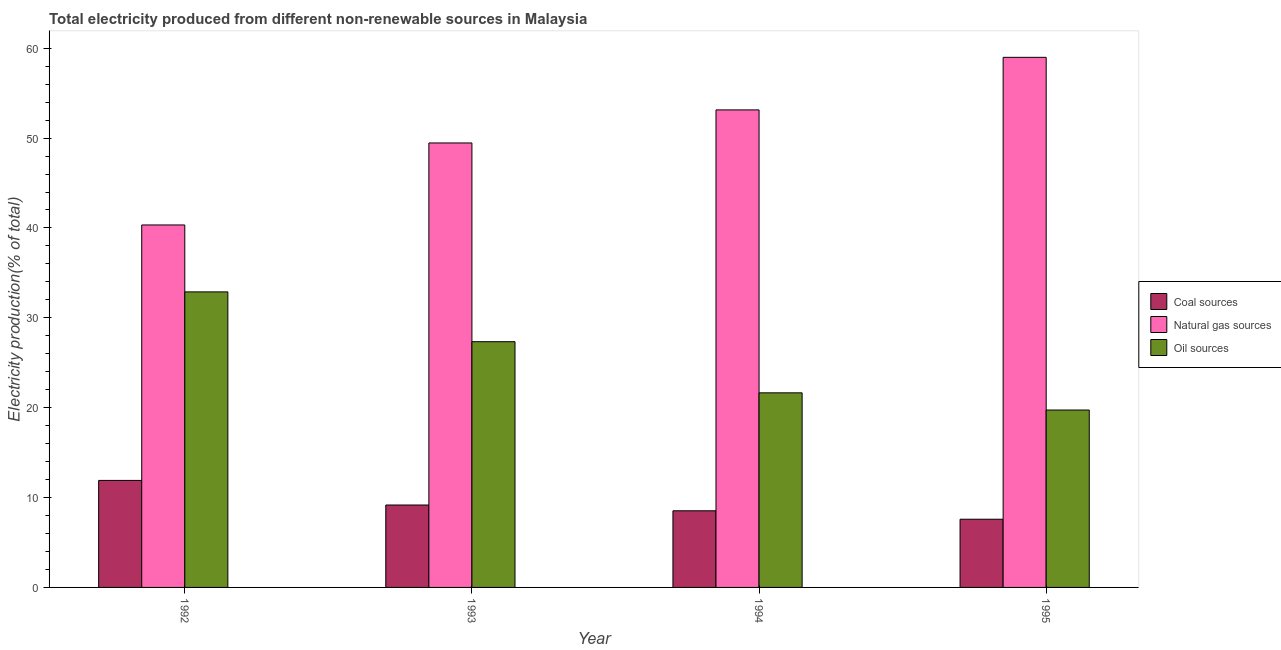How many groups of bars are there?
Keep it short and to the point. 4. What is the percentage of electricity produced by coal in 1994?
Keep it short and to the point. 8.53. Across all years, what is the maximum percentage of electricity produced by oil sources?
Make the answer very short. 32.89. Across all years, what is the minimum percentage of electricity produced by oil sources?
Your response must be concise. 19.74. In which year was the percentage of electricity produced by natural gas maximum?
Your answer should be compact. 1995. In which year was the percentage of electricity produced by coal minimum?
Offer a terse response. 1995. What is the total percentage of electricity produced by oil sources in the graph?
Provide a short and direct response. 101.62. What is the difference between the percentage of electricity produced by coal in 1993 and that in 1994?
Ensure brevity in your answer.  0.64. What is the difference between the percentage of electricity produced by natural gas in 1992 and the percentage of electricity produced by coal in 1995?
Keep it short and to the point. -18.65. What is the average percentage of electricity produced by oil sources per year?
Your answer should be very brief. 25.41. In how many years, is the percentage of electricity produced by coal greater than 8 %?
Provide a succinct answer. 3. What is the ratio of the percentage of electricity produced by oil sources in 1992 to that in 1993?
Offer a very short reply. 1.2. Is the percentage of electricity produced by natural gas in 1994 less than that in 1995?
Provide a short and direct response. Yes. What is the difference between the highest and the second highest percentage of electricity produced by coal?
Give a very brief answer. 2.74. What is the difference between the highest and the lowest percentage of electricity produced by oil sources?
Offer a terse response. 13.15. In how many years, is the percentage of electricity produced by oil sources greater than the average percentage of electricity produced by oil sources taken over all years?
Make the answer very short. 2. What does the 3rd bar from the left in 1994 represents?
Make the answer very short. Oil sources. What does the 1st bar from the right in 1994 represents?
Ensure brevity in your answer.  Oil sources. Is it the case that in every year, the sum of the percentage of electricity produced by coal and percentage of electricity produced by natural gas is greater than the percentage of electricity produced by oil sources?
Give a very brief answer. Yes. What is the difference between two consecutive major ticks on the Y-axis?
Make the answer very short. 10. Does the graph contain any zero values?
Make the answer very short. No. Does the graph contain grids?
Ensure brevity in your answer.  No. Where does the legend appear in the graph?
Provide a succinct answer. Center right. How many legend labels are there?
Offer a very short reply. 3. What is the title of the graph?
Provide a short and direct response. Total electricity produced from different non-renewable sources in Malaysia. What is the label or title of the Y-axis?
Offer a very short reply. Electricity production(% of total). What is the Electricity production(% of total) of Coal sources in 1992?
Offer a very short reply. 11.91. What is the Electricity production(% of total) of Natural gas sources in 1992?
Offer a very short reply. 40.33. What is the Electricity production(% of total) of Oil sources in 1992?
Give a very brief answer. 32.89. What is the Electricity production(% of total) in Coal sources in 1993?
Offer a terse response. 9.17. What is the Electricity production(% of total) of Natural gas sources in 1993?
Provide a short and direct response. 49.46. What is the Electricity production(% of total) in Oil sources in 1993?
Offer a terse response. 27.34. What is the Electricity production(% of total) in Coal sources in 1994?
Provide a short and direct response. 8.53. What is the Electricity production(% of total) of Natural gas sources in 1994?
Keep it short and to the point. 53.14. What is the Electricity production(% of total) in Oil sources in 1994?
Offer a terse response. 21.65. What is the Electricity production(% of total) of Coal sources in 1995?
Make the answer very short. 7.59. What is the Electricity production(% of total) in Natural gas sources in 1995?
Offer a very short reply. 58.99. What is the Electricity production(% of total) of Oil sources in 1995?
Your answer should be very brief. 19.74. Across all years, what is the maximum Electricity production(% of total) of Coal sources?
Your answer should be compact. 11.91. Across all years, what is the maximum Electricity production(% of total) in Natural gas sources?
Your answer should be very brief. 58.99. Across all years, what is the maximum Electricity production(% of total) in Oil sources?
Give a very brief answer. 32.89. Across all years, what is the minimum Electricity production(% of total) of Coal sources?
Offer a terse response. 7.59. Across all years, what is the minimum Electricity production(% of total) of Natural gas sources?
Keep it short and to the point. 40.33. Across all years, what is the minimum Electricity production(% of total) of Oil sources?
Offer a very short reply. 19.74. What is the total Electricity production(% of total) of Coal sources in the graph?
Make the answer very short. 37.19. What is the total Electricity production(% of total) of Natural gas sources in the graph?
Offer a terse response. 201.91. What is the total Electricity production(% of total) in Oil sources in the graph?
Provide a short and direct response. 101.62. What is the difference between the Electricity production(% of total) in Coal sources in 1992 and that in 1993?
Offer a very short reply. 2.74. What is the difference between the Electricity production(% of total) of Natural gas sources in 1992 and that in 1993?
Ensure brevity in your answer.  -9.13. What is the difference between the Electricity production(% of total) in Oil sources in 1992 and that in 1993?
Give a very brief answer. 5.54. What is the difference between the Electricity production(% of total) in Coal sources in 1992 and that in 1994?
Provide a short and direct response. 3.38. What is the difference between the Electricity production(% of total) of Natural gas sources in 1992 and that in 1994?
Provide a short and direct response. -12.8. What is the difference between the Electricity production(% of total) of Oil sources in 1992 and that in 1994?
Your answer should be compact. 11.23. What is the difference between the Electricity production(% of total) of Coal sources in 1992 and that in 1995?
Make the answer very short. 4.32. What is the difference between the Electricity production(% of total) of Natural gas sources in 1992 and that in 1995?
Offer a terse response. -18.65. What is the difference between the Electricity production(% of total) of Oil sources in 1992 and that in 1995?
Give a very brief answer. 13.15. What is the difference between the Electricity production(% of total) in Coal sources in 1993 and that in 1994?
Provide a short and direct response. 0.64. What is the difference between the Electricity production(% of total) of Natural gas sources in 1993 and that in 1994?
Your answer should be very brief. -3.68. What is the difference between the Electricity production(% of total) of Oil sources in 1993 and that in 1994?
Your answer should be very brief. 5.69. What is the difference between the Electricity production(% of total) in Coal sources in 1993 and that in 1995?
Your answer should be very brief. 1.58. What is the difference between the Electricity production(% of total) in Natural gas sources in 1993 and that in 1995?
Ensure brevity in your answer.  -9.53. What is the difference between the Electricity production(% of total) of Oil sources in 1993 and that in 1995?
Give a very brief answer. 7.6. What is the difference between the Electricity production(% of total) in Coal sources in 1994 and that in 1995?
Your answer should be very brief. 0.94. What is the difference between the Electricity production(% of total) in Natural gas sources in 1994 and that in 1995?
Your answer should be compact. -5.85. What is the difference between the Electricity production(% of total) of Oil sources in 1994 and that in 1995?
Provide a short and direct response. 1.91. What is the difference between the Electricity production(% of total) of Coal sources in 1992 and the Electricity production(% of total) of Natural gas sources in 1993?
Ensure brevity in your answer.  -37.55. What is the difference between the Electricity production(% of total) in Coal sources in 1992 and the Electricity production(% of total) in Oil sources in 1993?
Provide a short and direct response. -15.44. What is the difference between the Electricity production(% of total) of Natural gas sources in 1992 and the Electricity production(% of total) of Oil sources in 1993?
Your answer should be compact. 12.99. What is the difference between the Electricity production(% of total) of Coal sources in 1992 and the Electricity production(% of total) of Natural gas sources in 1994?
Keep it short and to the point. -41.23. What is the difference between the Electricity production(% of total) of Coal sources in 1992 and the Electricity production(% of total) of Oil sources in 1994?
Keep it short and to the point. -9.75. What is the difference between the Electricity production(% of total) in Natural gas sources in 1992 and the Electricity production(% of total) in Oil sources in 1994?
Provide a succinct answer. 18.68. What is the difference between the Electricity production(% of total) in Coal sources in 1992 and the Electricity production(% of total) in Natural gas sources in 1995?
Offer a very short reply. -47.08. What is the difference between the Electricity production(% of total) of Coal sources in 1992 and the Electricity production(% of total) of Oil sources in 1995?
Ensure brevity in your answer.  -7.83. What is the difference between the Electricity production(% of total) in Natural gas sources in 1992 and the Electricity production(% of total) in Oil sources in 1995?
Provide a short and direct response. 20.59. What is the difference between the Electricity production(% of total) in Coal sources in 1993 and the Electricity production(% of total) in Natural gas sources in 1994?
Keep it short and to the point. -43.96. What is the difference between the Electricity production(% of total) of Coal sources in 1993 and the Electricity production(% of total) of Oil sources in 1994?
Provide a succinct answer. -12.48. What is the difference between the Electricity production(% of total) in Natural gas sources in 1993 and the Electricity production(% of total) in Oil sources in 1994?
Provide a succinct answer. 27.81. What is the difference between the Electricity production(% of total) in Coal sources in 1993 and the Electricity production(% of total) in Natural gas sources in 1995?
Your response must be concise. -49.81. What is the difference between the Electricity production(% of total) in Coal sources in 1993 and the Electricity production(% of total) in Oil sources in 1995?
Make the answer very short. -10.57. What is the difference between the Electricity production(% of total) in Natural gas sources in 1993 and the Electricity production(% of total) in Oil sources in 1995?
Offer a very short reply. 29.72. What is the difference between the Electricity production(% of total) in Coal sources in 1994 and the Electricity production(% of total) in Natural gas sources in 1995?
Offer a very short reply. -50.46. What is the difference between the Electricity production(% of total) in Coal sources in 1994 and the Electricity production(% of total) in Oil sources in 1995?
Give a very brief answer. -11.21. What is the difference between the Electricity production(% of total) in Natural gas sources in 1994 and the Electricity production(% of total) in Oil sources in 1995?
Keep it short and to the point. 33.4. What is the average Electricity production(% of total) of Coal sources per year?
Make the answer very short. 9.3. What is the average Electricity production(% of total) in Natural gas sources per year?
Keep it short and to the point. 50.48. What is the average Electricity production(% of total) in Oil sources per year?
Provide a short and direct response. 25.41. In the year 1992, what is the difference between the Electricity production(% of total) in Coal sources and Electricity production(% of total) in Natural gas sources?
Make the answer very short. -28.43. In the year 1992, what is the difference between the Electricity production(% of total) in Coal sources and Electricity production(% of total) in Oil sources?
Your answer should be compact. -20.98. In the year 1992, what is the difference between the Electricity production(% of total) in Natural gas sources and Electricity production(% of total) in Oil sources?
Offer a terse response. 7.45. In the year 1993, what is the difference between the Electricity production(% of total) in Coal sources and Electricity production(% of total) in Natural gas sources?
Provide a short and direct response. -40.29. In the year 1993, what is the difference between the Electricity production(% of total) of Coal sources and Electricity production(% of total) of Oil sources?
Your response must be concise. -18.17. In the year 1993, what is the difference between the Electricity production(% of total) in Natural gas sources and Electricity production(% of total) in Oil sources?
Provide a succinct answer. 22.11. In the year 1994, what is the difference between the Electricity production(% of total) in Coal sources and Electricity production(% of total) in Natural gas sources?
Ensure brevity in your answer.  -44.61. In the year 1994, what is the difference between the Electricity production(% of total) of Coal sources and Electricity production(% of total) of Oil sources?
Provide a short and direct response. -13.13. In the year 1994, what is the difference between the Electricity production(% of total) of Natural gas sources and Electricity production(% of total) of Oil sources?
Provide a succinct answer. 31.48. In the year 1995, what is the difference between the Electricity production(% of total) in Coal sources and Electricity production(% of total) in Natural gas sources?
Your answer should be very brief. -51.4. In the year 1995, what is the difference between the Electricity production(% of total) of Coal sources and Electricity production(% of total) of Oil sources?
Ensure brevity in your answer.  -12.15. In the year 1995, what is the difference between the Electricity production(% of total) of Natural gas sources and Electricity production(% of total) of Oil sources?
Offer a very short reply. 39.25. What is the ratio of the Electricity production(% of total) in Coal sources in 1992 to that in 1993?
Offer a very short reply. 1.3. What is the ratio of the Electricity production(% of total) in Natural gas sources in 1992 to that in 1993?
Offer a terse response. 0.82. What is the ratio of the Electricity production(% of total) in Oil sources in 1992 to that in 1993?
Make the answer very short. 1.2. What is the ratio of the Electricity production(% of total) of Coal sources in 1992 to that in 1994?
Your response must be concise. 1.4. What is the ratio of the Electricity production(% of total) of Natural gas sources in 1992 to that in 1994?
Ensure brevity in your answer.  0.76. What is the ratio of the Electricity production(% of total) of Oil sources in 1992 to that in 1994?
Your answer should be very brief. 1.52. What is the ratio of the Electricity production(% of total) in Coal sources in 1992 to that in 1995?
Ensure brevity in your answer.  1.57. What is the ratio of the Electricity production(% of total) of Natural gas sources in 1992 to that in 1995?
Your answer should be very brief. 0.68. What is the ratio of the Electricity production(% of total) in Oil sources in 1992 to that in 1995?
Ensure brevity in your answer.  1.67. What is the ratio of the Electricity production(% of total) in Coal sources in 1993 to that in 1994?
Offer a terse response. 1.08. What is the ratio of the Electricity production(% of total) in Natural gas sources in 1993 to that in 1994?
Ensure brevity in your answer.  0.93. What is the ratio of the Electricity production(% of total) of Oil sources in 1993 to that in 1994?
Give a very brief answer. 1.26. What is the ratio of the Electricity production(% of total) in Coal sources in 1993 to that in 1995?
Provide a succinct answer. 1.21. What is the ratio of the Electricity production(% of total) in Natural gas sources in 1993 to that in 1995?
Provide a succinct answer. 0.84. What is the ratio of the Electricity production(% of total) in Oil sources in 1993 to that in 1995?
Your answer should be very brief. 1.39. What is the ratio of the Electricity production(% of total) of Coal sources in 1994 to that in 1995?
Offer a terse response. 1.12. What is the ratio of the Electricity production(% of total) of Natural gas sources in 1994 to that in 1995?
Ensure brevity in your answer.  0.9. What is the ratio of the Electricity production(% of total) of Oil sources in 1994 to that in 1995?
Offer a very short reply. 1.1. What is the difference between the highest and the second highest Electricity production(% of total) in Coal sources?
Offer a terse response. 2.74. What is the difference between the highest and the second highest Electricity production(% of total) of Natural gas sources?
Ensure brevity in your answer.  5.85. What is the difference between the highest and the second highest Electricity production(% of total) of Oil sources?
Provide a succinct answer. 5.54. What is the difference between the highest and the lowest Electricity production(% of total) of Coal sources?
Your answer should be compact. 4.32. What is the difference between the highest and the lowest Electricity production(% of total) in Natural gas sources?
Your response must be concise. 18.65. What is the difference between the highest and the lowest Electricity production(% of total) of Oil sources?
Make the answer very short. 13.15. 